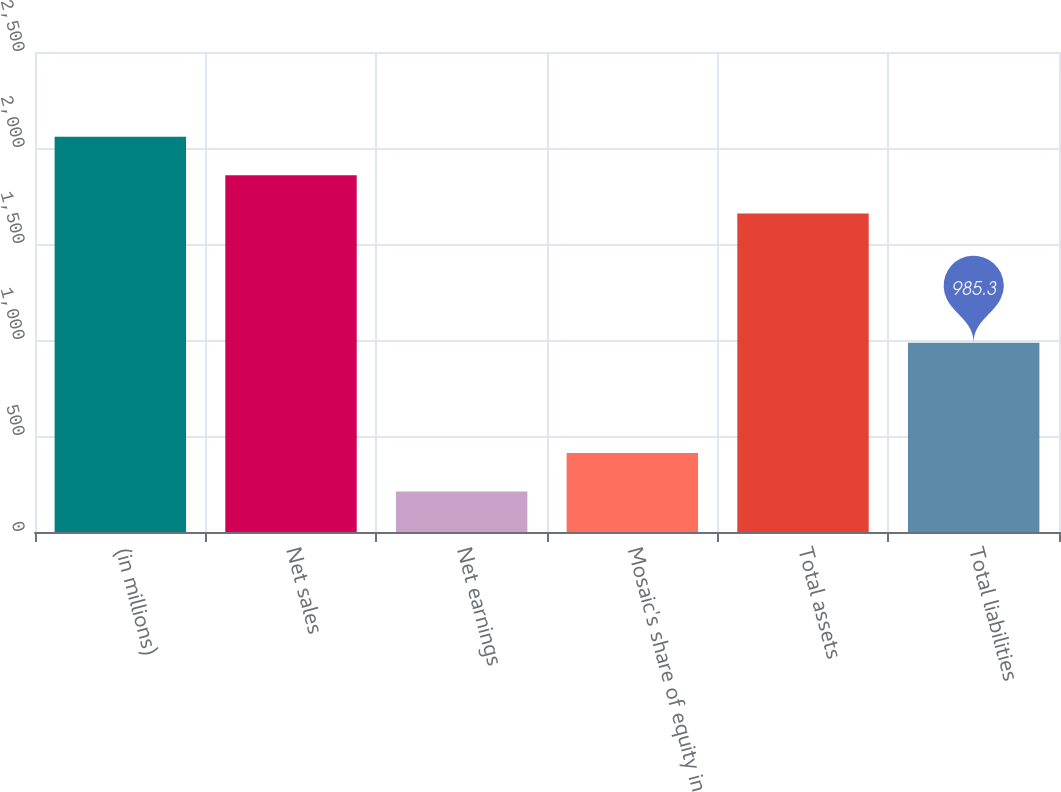<chart> <loc_0><loc_0><loc_500><loc_500><bar_chart><fcel>(in millions)<fcel>Net sales<fcel>Net earnings<fcel>Mosaic's share of equity in<fcel>Total assets<fcel>Total liabilities<nl><fcel>2058.92<fcel>1858.71<fcel>211.11<fcel>411.32<fcel>1658.5<fcel>985.3<nl></chart> 